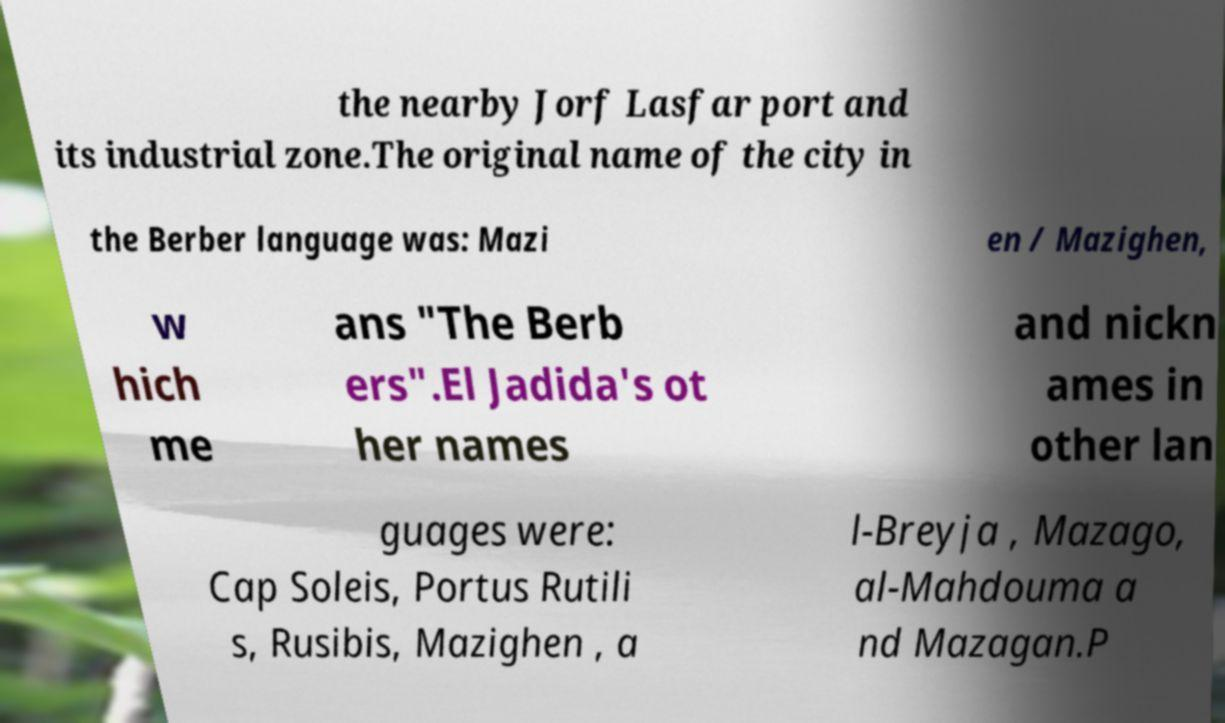Can you accurately transcribe the text from the provided image for me? the nearby Jorf Lasfar port and its industrial zone.The original name of the city in the Berber language was: Mazi en / Mazighen, w hich me ans "The Berb ers".El Jadida's ot her names and nickn ames in other lan guages were: Cap Soleis, Portus Rutili s, Rusibis, Mazighen , a l-Breyja , Mazago, al-Mahdouma a nd Mazagan.P 